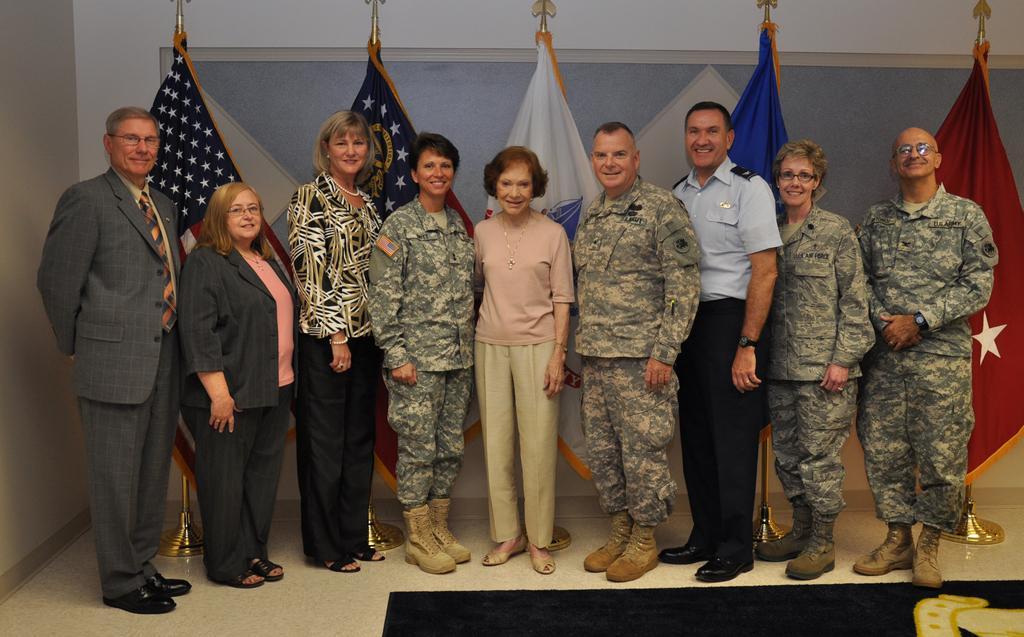Could you give a brief overview of what you see in this image? This picture is clicked inside. In the foreground there is a black color object placed on the ground. In the center we can see the group of men and women smiling and standing on the ground. In the background there is a wall and many number of flags which are of different colors. 